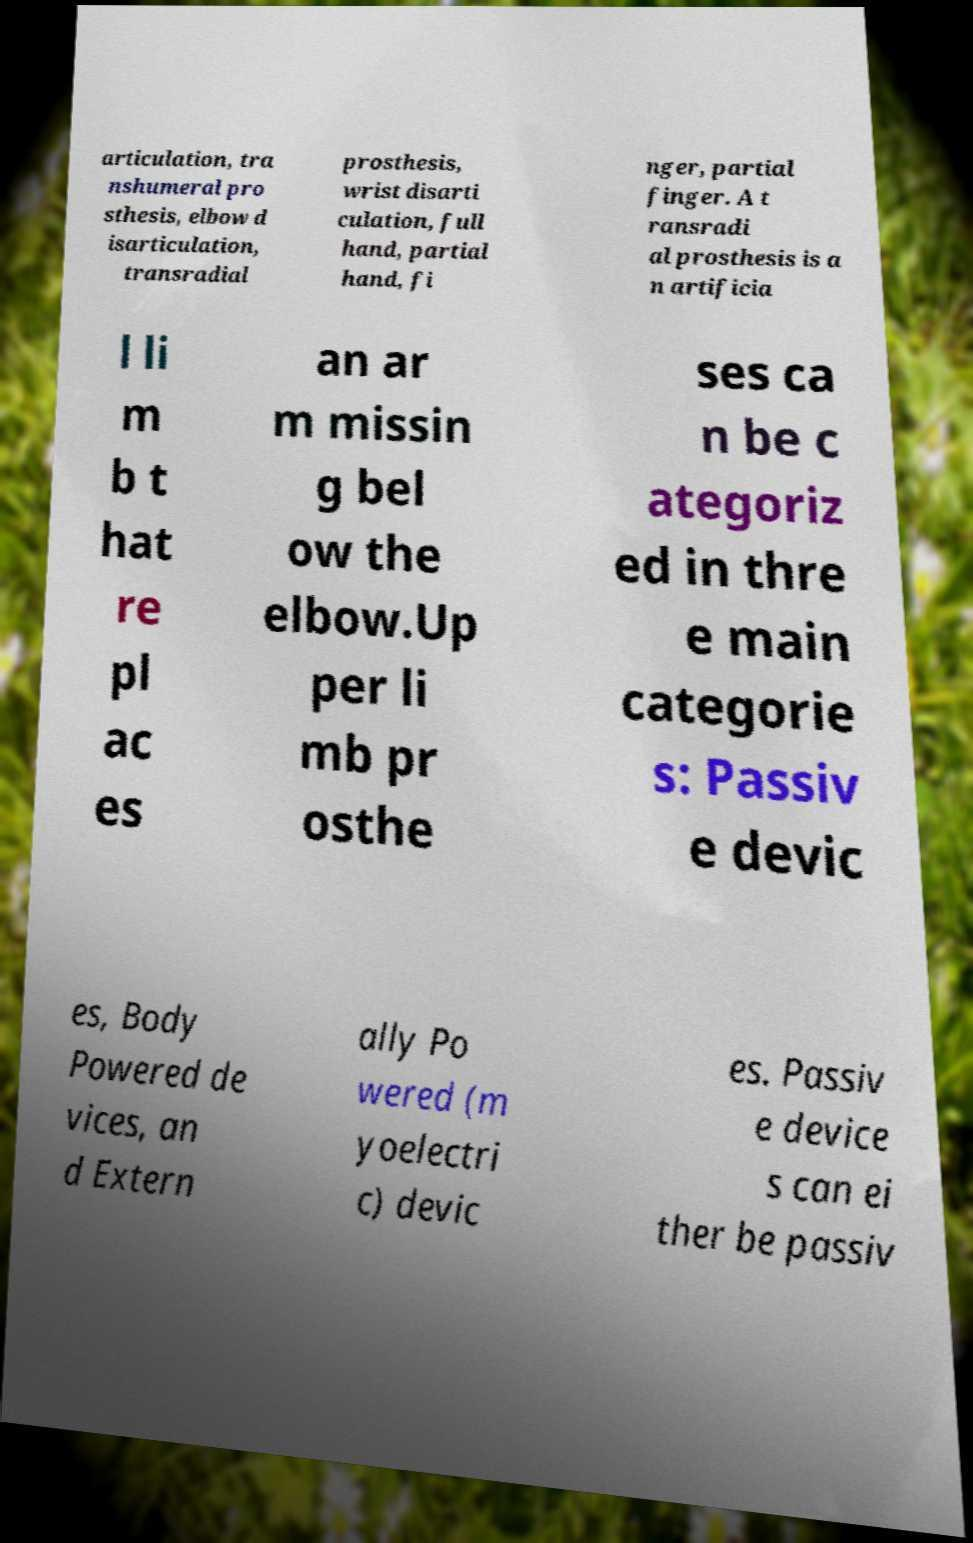Please identify and transcribe the text found in this image. articulation, tra nshumeral pro sthesis, elbow d isarticulation, transradial prosthesis, wrist disarti culation, full hand, partial hand, fi nger, partial finger. A t ransradi al prosthesis is a n artificia l li m b t hat re pl ac es an ar m missin g bel ow the elbow.Up per li mb pr osthe ses ca n be c ategoriz ed in thre e main categorie s: Passiv e devic es, Body Powered de vices, an d Extern ally Po wered (m yoelectri c) devic es. Passiv e device s can ei ther be passiv 